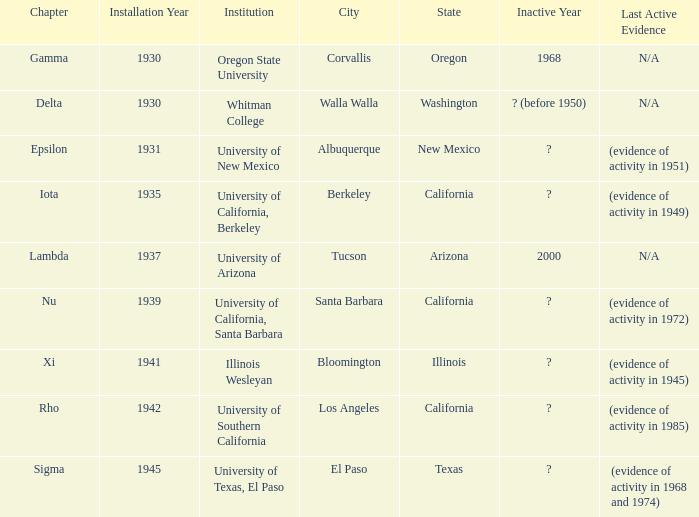What is the chapter for Illinois Wesleyan?  Xi. 